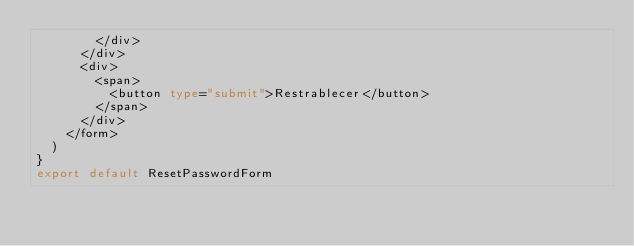<code> <loc_0><loc_0><loc_500><loc_500><_TypeScript_>        </div>
      </div>
      <div>
        <span>
          <button type="submit">Restrablecer</button>
        </span>
      </div>
    </form>
  )
}
export default ResetPasswordForm
</code> 